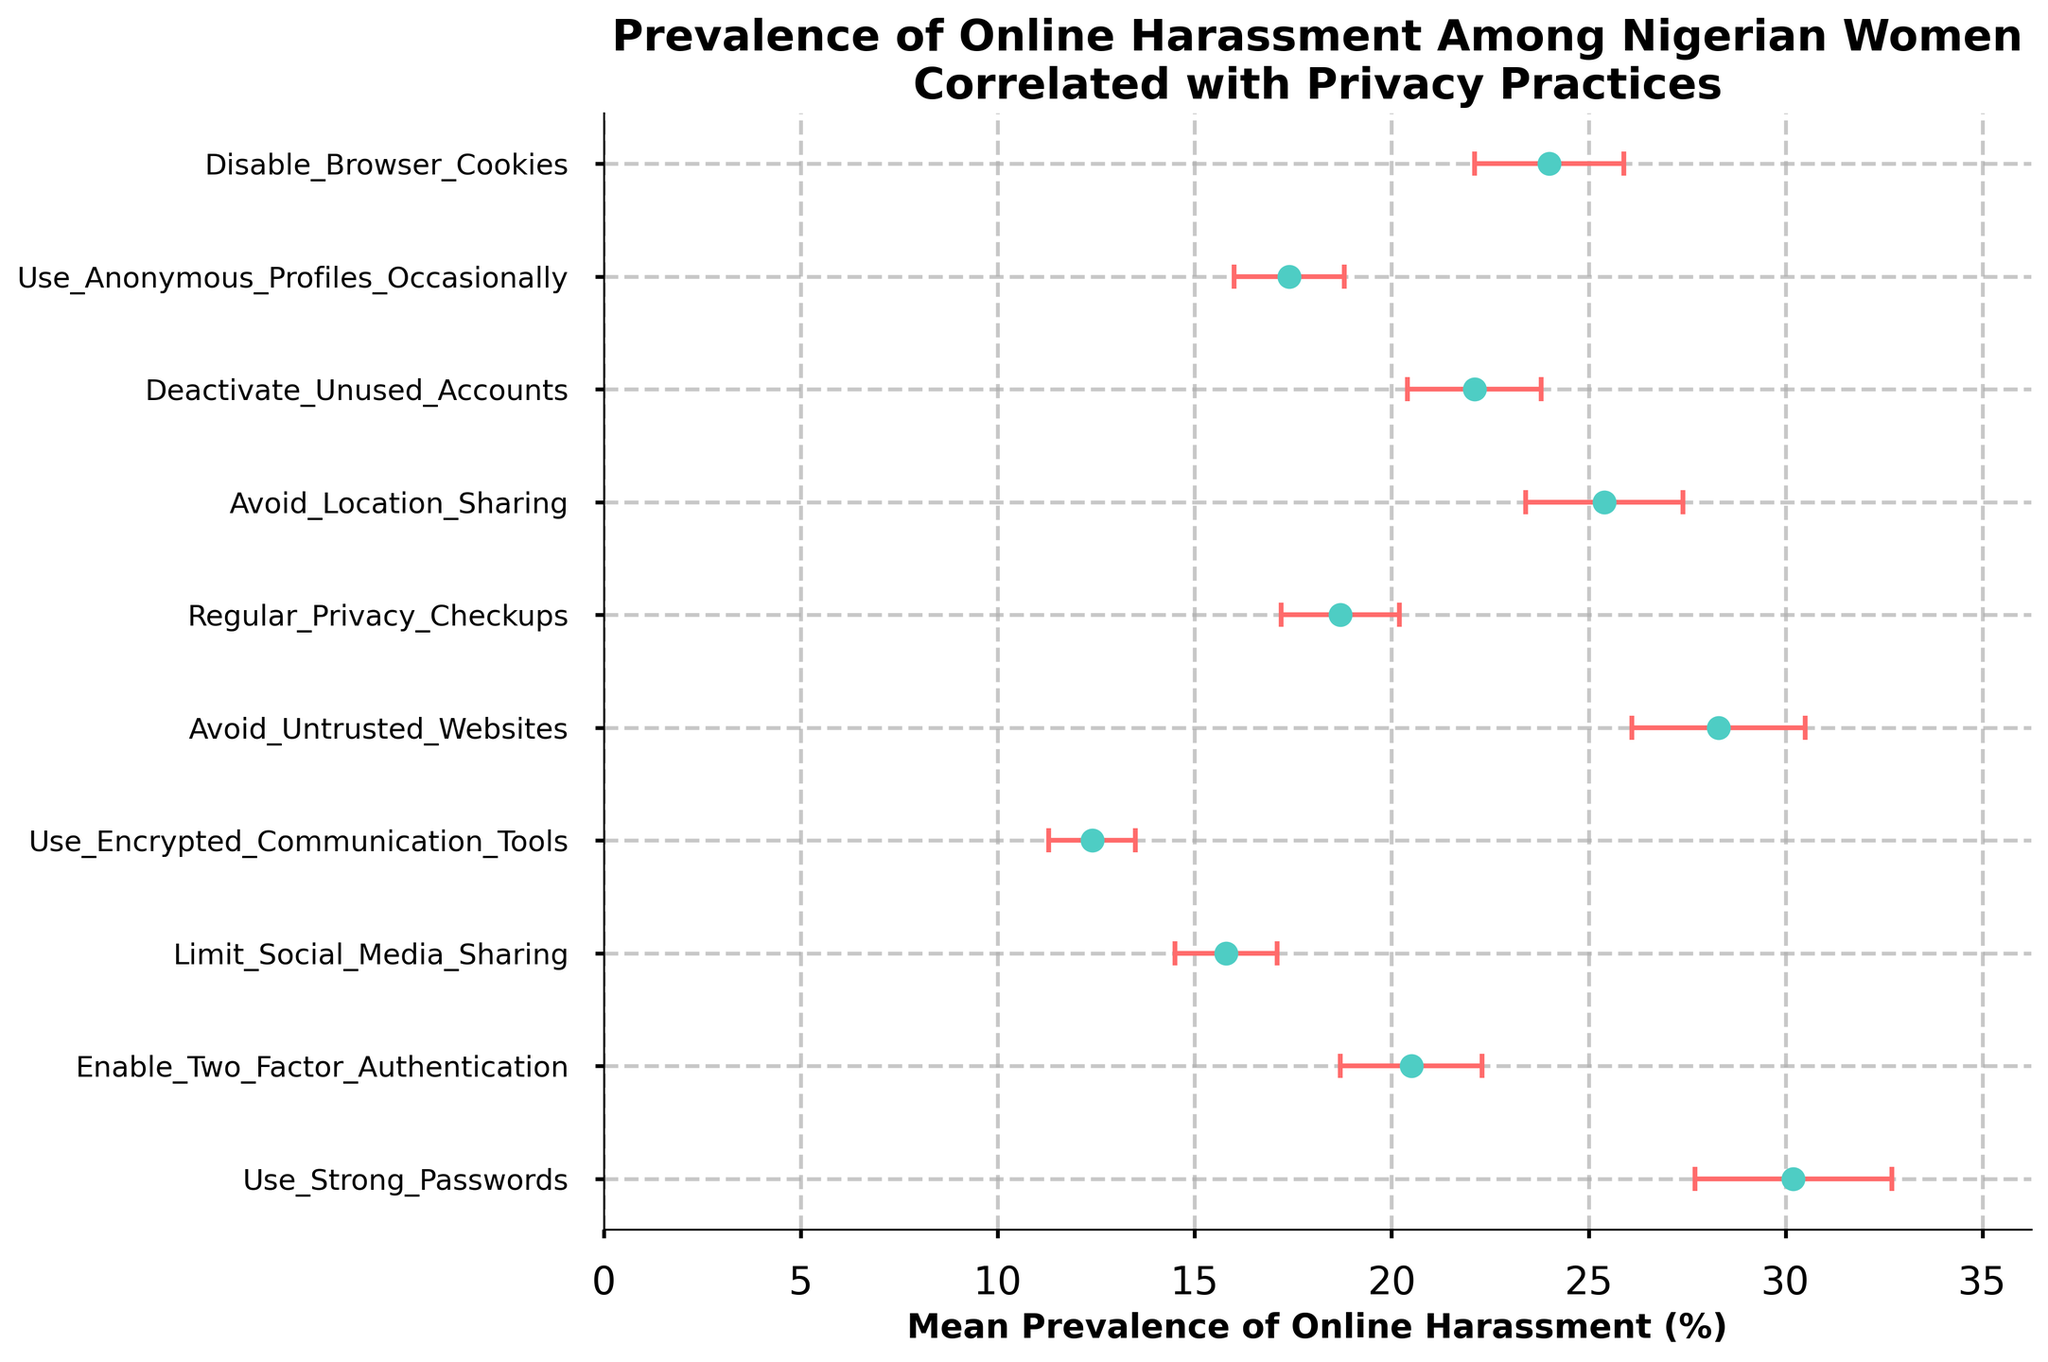What is the title of the plot? The title of the plot is displayed at the top of the figure.
Answer: Prevalence of Online Harassment Among Nigerian Women Correlated with Privacy Practices How many privacy practices are presented in the plot? Count the number of names on the y-axis.
Answer: 10 Which privacy practice is associated with the lowest mean prevalence of online harassment? Identify the privacy practice with the smallest data point on the x-axis.
Answer: Use Encrypted Communication Tools What is the mean prevalence of online harassment for people enabling two-factor authentication? Locate the data point corresponding to "Enable Two-Factor Authentication" and read its value on the x-axis.
Answer: 20.5% Which privacy practice has the highest uncertainty in measurement? Determine the data point with the largest error bar.
Answer: Use Strong Passwords How does the mean prevalence of online harassment for people who limit social media sharing compare to those who avoid location sharing? Compare the x-values for "Limit Social Media Sharing" and "Avoid Location Sharing". The former is 15.8% and the latter is 25.4%.
Answer: Limit Social Media Sharing has a lower mean prevalence What is the range of mean prevalence of online harassment for all privacy practices? Find the difference between the highest and lowest mean prevalence values on the x-axis. The highest is 30.2% and the lowest is 12.4%.
Answer: 30.2% - 12.4% = 17.8% What is the average mean prevalence of online harassment for the privacy practices that are above 20%? Identify the data points above 20%, sum their mean values, and divide by the number of data points. Practices: Use Strong Passwords, Avoid Untrusted Websites, Avoid Location Sharing, Deactivate Unused Accounts, Disable Browser Cookies. Their means are 30.2, 28.3, 25.4, 22.1, 24.0. Sum = 130.0, number of practices = 5. Average = 130.0 / 5 = 26.0.
Answer: 26.0% Which privacy practice has a mean prevalence of online harassment closest to 20%? Identify which data point is nearest to 20% on the x-axis.
Answer: Deactivate Unused Accounts Is the mean prevalence of online harassment for people who use anonymous profiles occasionally higher or lower than those who perform regular privacy checkups? Compare the x-values of "Use Anonymous Profiles Occasionally" and "Regular Privacy Checkups". The former is 17.4% and the latter is 18.7%.
Answer: Lower 